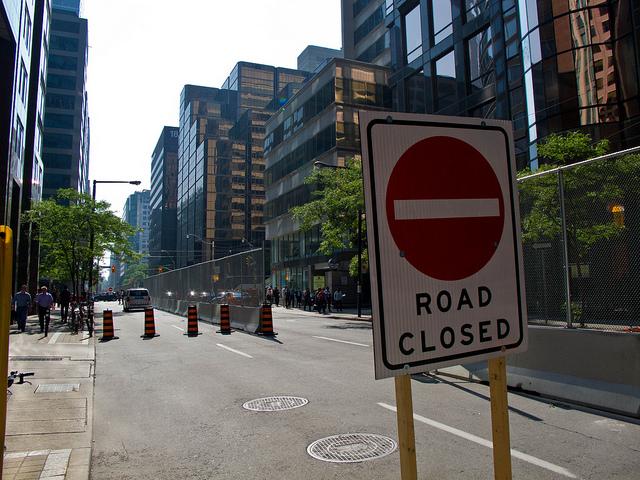What color is the door?
Write a very short answer. Clear glass. Is the traffic congested?
Quick response, please. No. Are there any people on the sidewalk?
Give a very brief answer. Yes. How many manhole covers are shown?
Quick response, please. 2. What is wrote on the road?
Concise answer only. Road closed. What is the red object?
Concise answer only. Circle. 